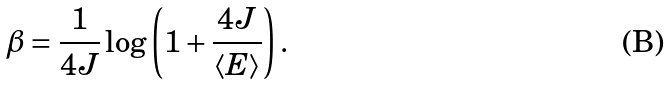Convert formula to latex. <formula><loc_0><loc_0><loc_500><loc_500>\beta = \frac { 1 } { 4 J } \log \left ( 1 + \frac { 4 J } { \langle E \rangle } \right ) .</formula> 